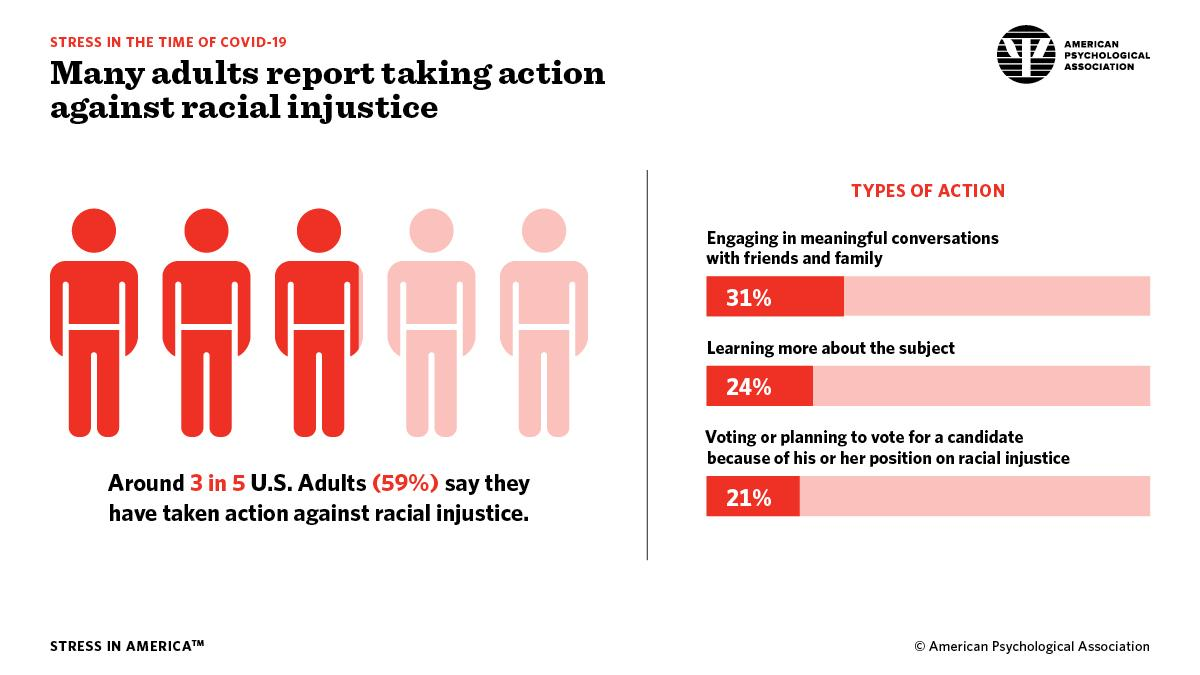Point out several critical features in this image. Out of 5, only 2 have not taken action against racial injustice. According to a recent survey, 69% of adults are not engaged in meaningful conversations with friends and family. According to a recent survey, 41% of adults have not taken action against racial injustice. According to a recent study, 76% of adults are not learning about the subject. 